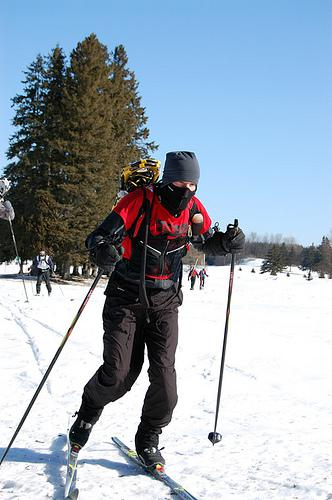Question: who has on a black hat?
Choices:
A. The person skiing.
B. The man hiking.
C. The child sledding.
D. The woman skating.
Answer with the letter. Answer: A Question: what is on the ground?
Choices:
A. Mud.
B. Ice.
C. Gravel.
D. Snow.
Answer with the letter. Answer: D Question: what does the person have on their face?
Choices:
A. Sunblock.
B. Glasses.
C. A visor.
D. A ski mask.
Answer with the letter. Answer: D Question: what type of pants is the person wearing?
Choices:
A. Ski pants.
B. Snow pants.
C. Dress slacks.
D. Sweat pants.
Answer with the letter. Answer: A Question: when was this picture taken?
Choices:
A. Yesterday.
B. At night.
C. During the day.
D. During dinner.
Answer with the letter. Answer: C 